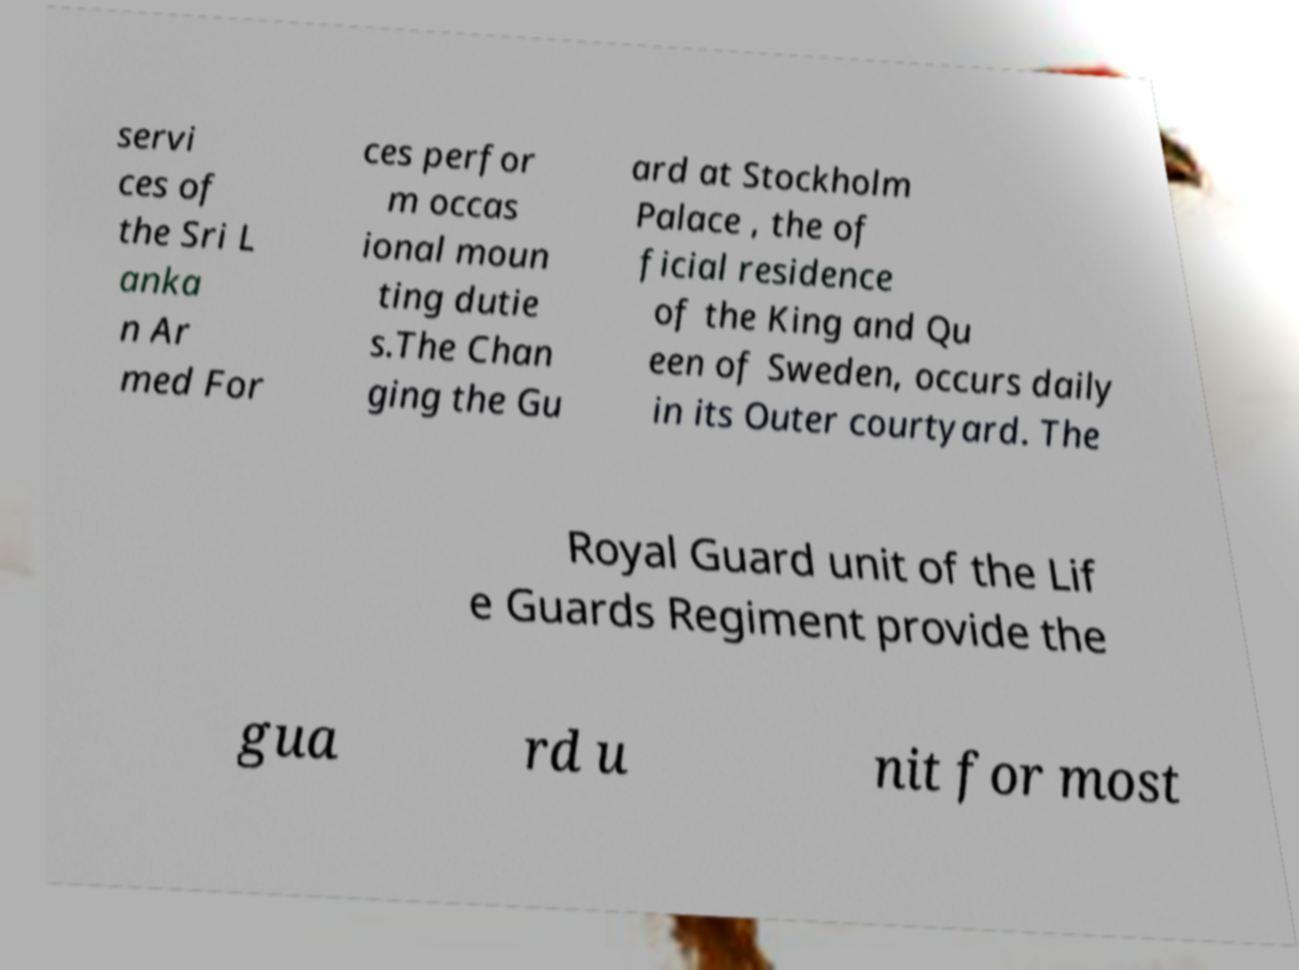For documentation purposes, I need the text within this image transcribed. Could you provide that? servi ces of the Sri L anka n Ar med For ces perfor m occas ional moun ting dutie s.The Chan ging the Gu ard at Stockholm Palace , the of ficial residence of the King and Qu een of Sweden, occurs daily in its Outer courtyard. The Royal Guard unit of the Lif e Guards Regiment provide the gua rd u nit for most 